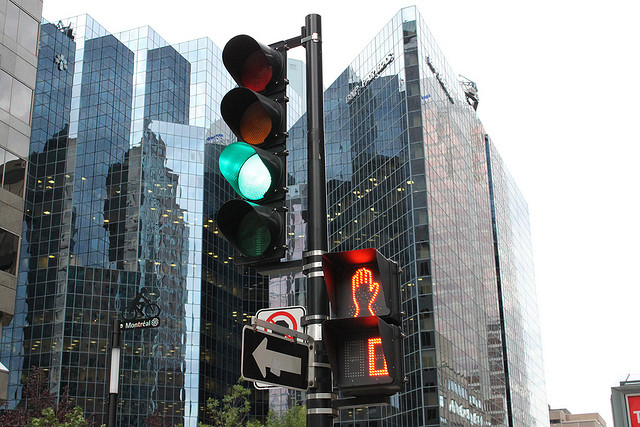Is there any indication of the location where this picture might have been taken? There is a street sign that reads "Montreal", which suggests this photo was taken in the city of Montreal, Canada. The contemporary architecture also aligns with a metropolitan area. 